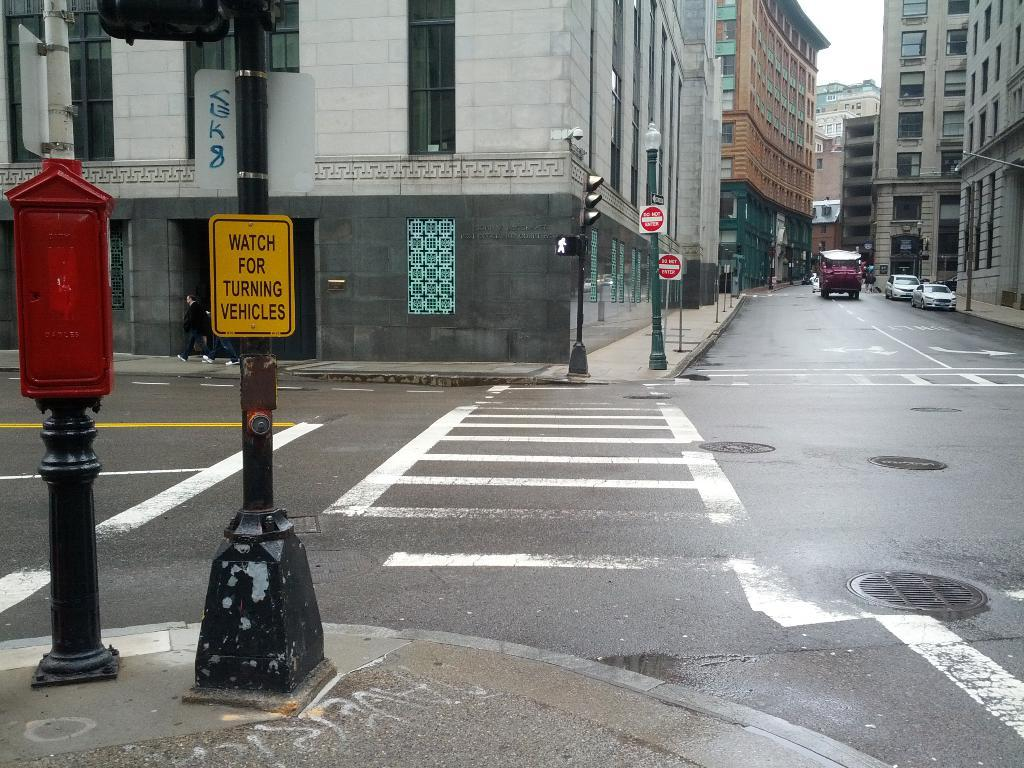<image>
Render a clear and concise summary of the photo. A street corner that has a sign cautioning people to watch for turning vehicles. 